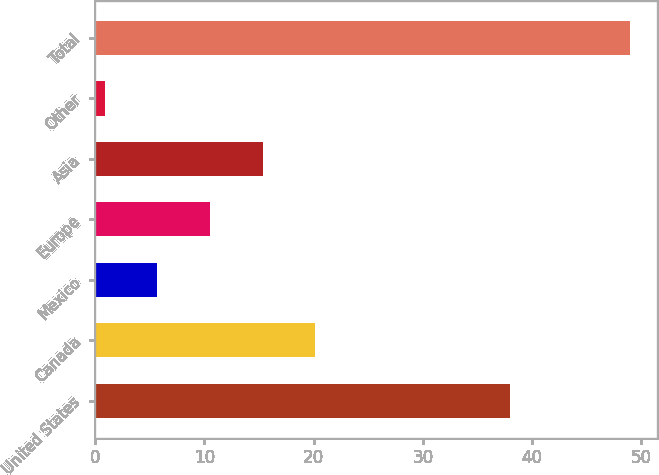Convert chart. <chart><loc_0><loc_0><loc_500><loc_500><bar_chart><fcel>United States<fcel>Canada<fcel>Mexico<fcel>Europe<fcel>Asia<fcel>Other<fcel>Total<nl><fcel>38<fcel>20.14<fcel>5.71<fcel>10.52<fcel>15.33<fcel>0.9<fcel>49<nl></chart> 